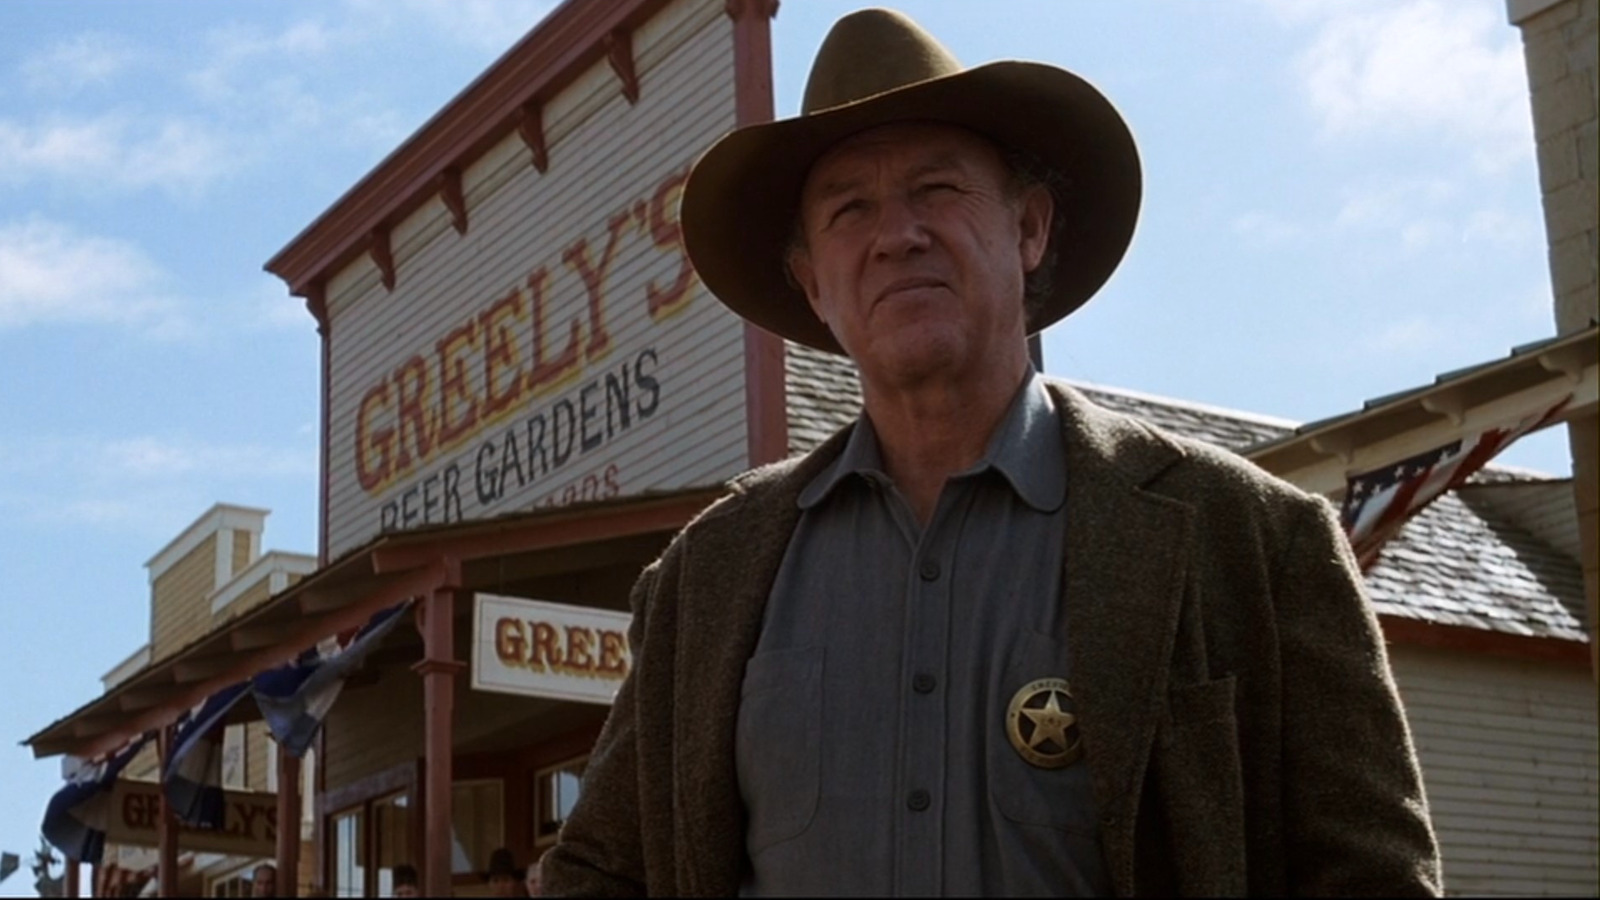Who is the character seen in the image? The character in the image appears to be a sheriff from the old west, as indicated by his attire, including the cowboy hat, gray jacket, and prominent gold badge. 